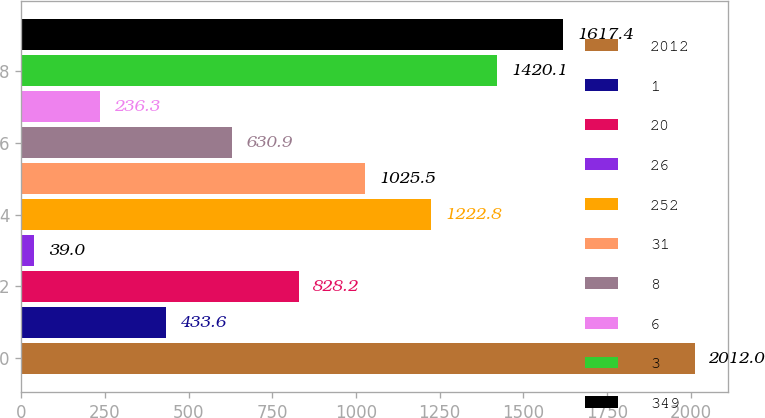Convert chart to OTSL. <chart><loc_0><loc_0><loc_500><loc_500><bar_chart><fcel>2012<fcel>1<fcel>20<fcel>26<fcel>252<fcel>31<fcel>8<fcel>6<fcel>3<fcel>349<nl><fcel>2012<fcel>433.6<fcel>828.2<fcel>39<fcel>1222.8<fcel>1025.5<fcel>630.9<fcel>236.3<fcel>1420.1<fcel>1617.4<nl></chart> 